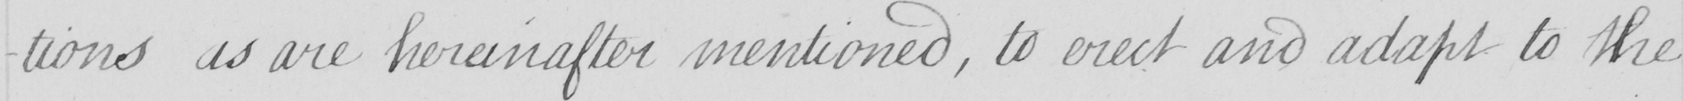Can you read and transcribe this handwriting? -tions as are hereinafter mentioned , to erect and adapt to the 